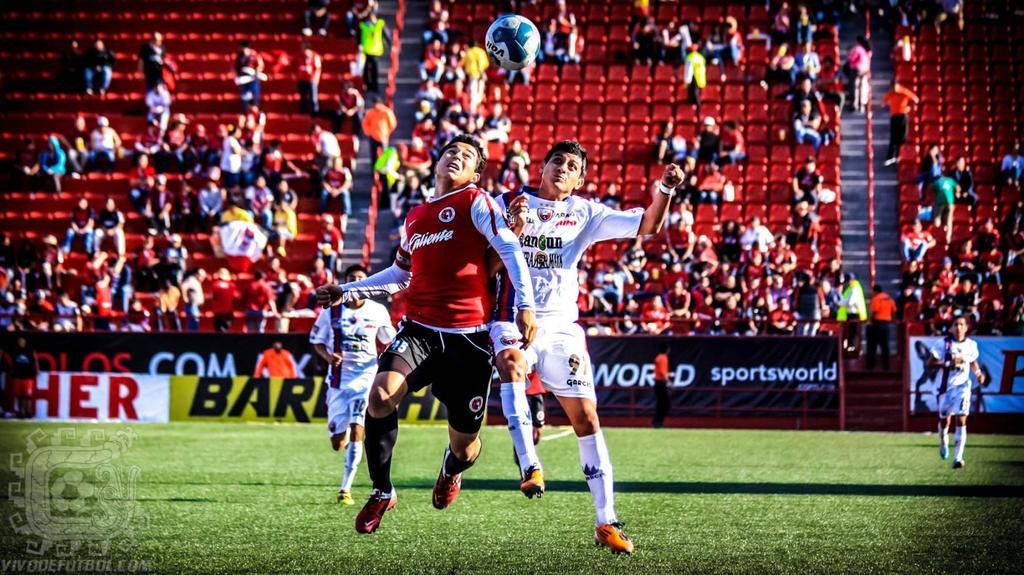<image>
Present a compact description of the photo's key features. The Caliente player battles with his opponent for the soccer ball. 